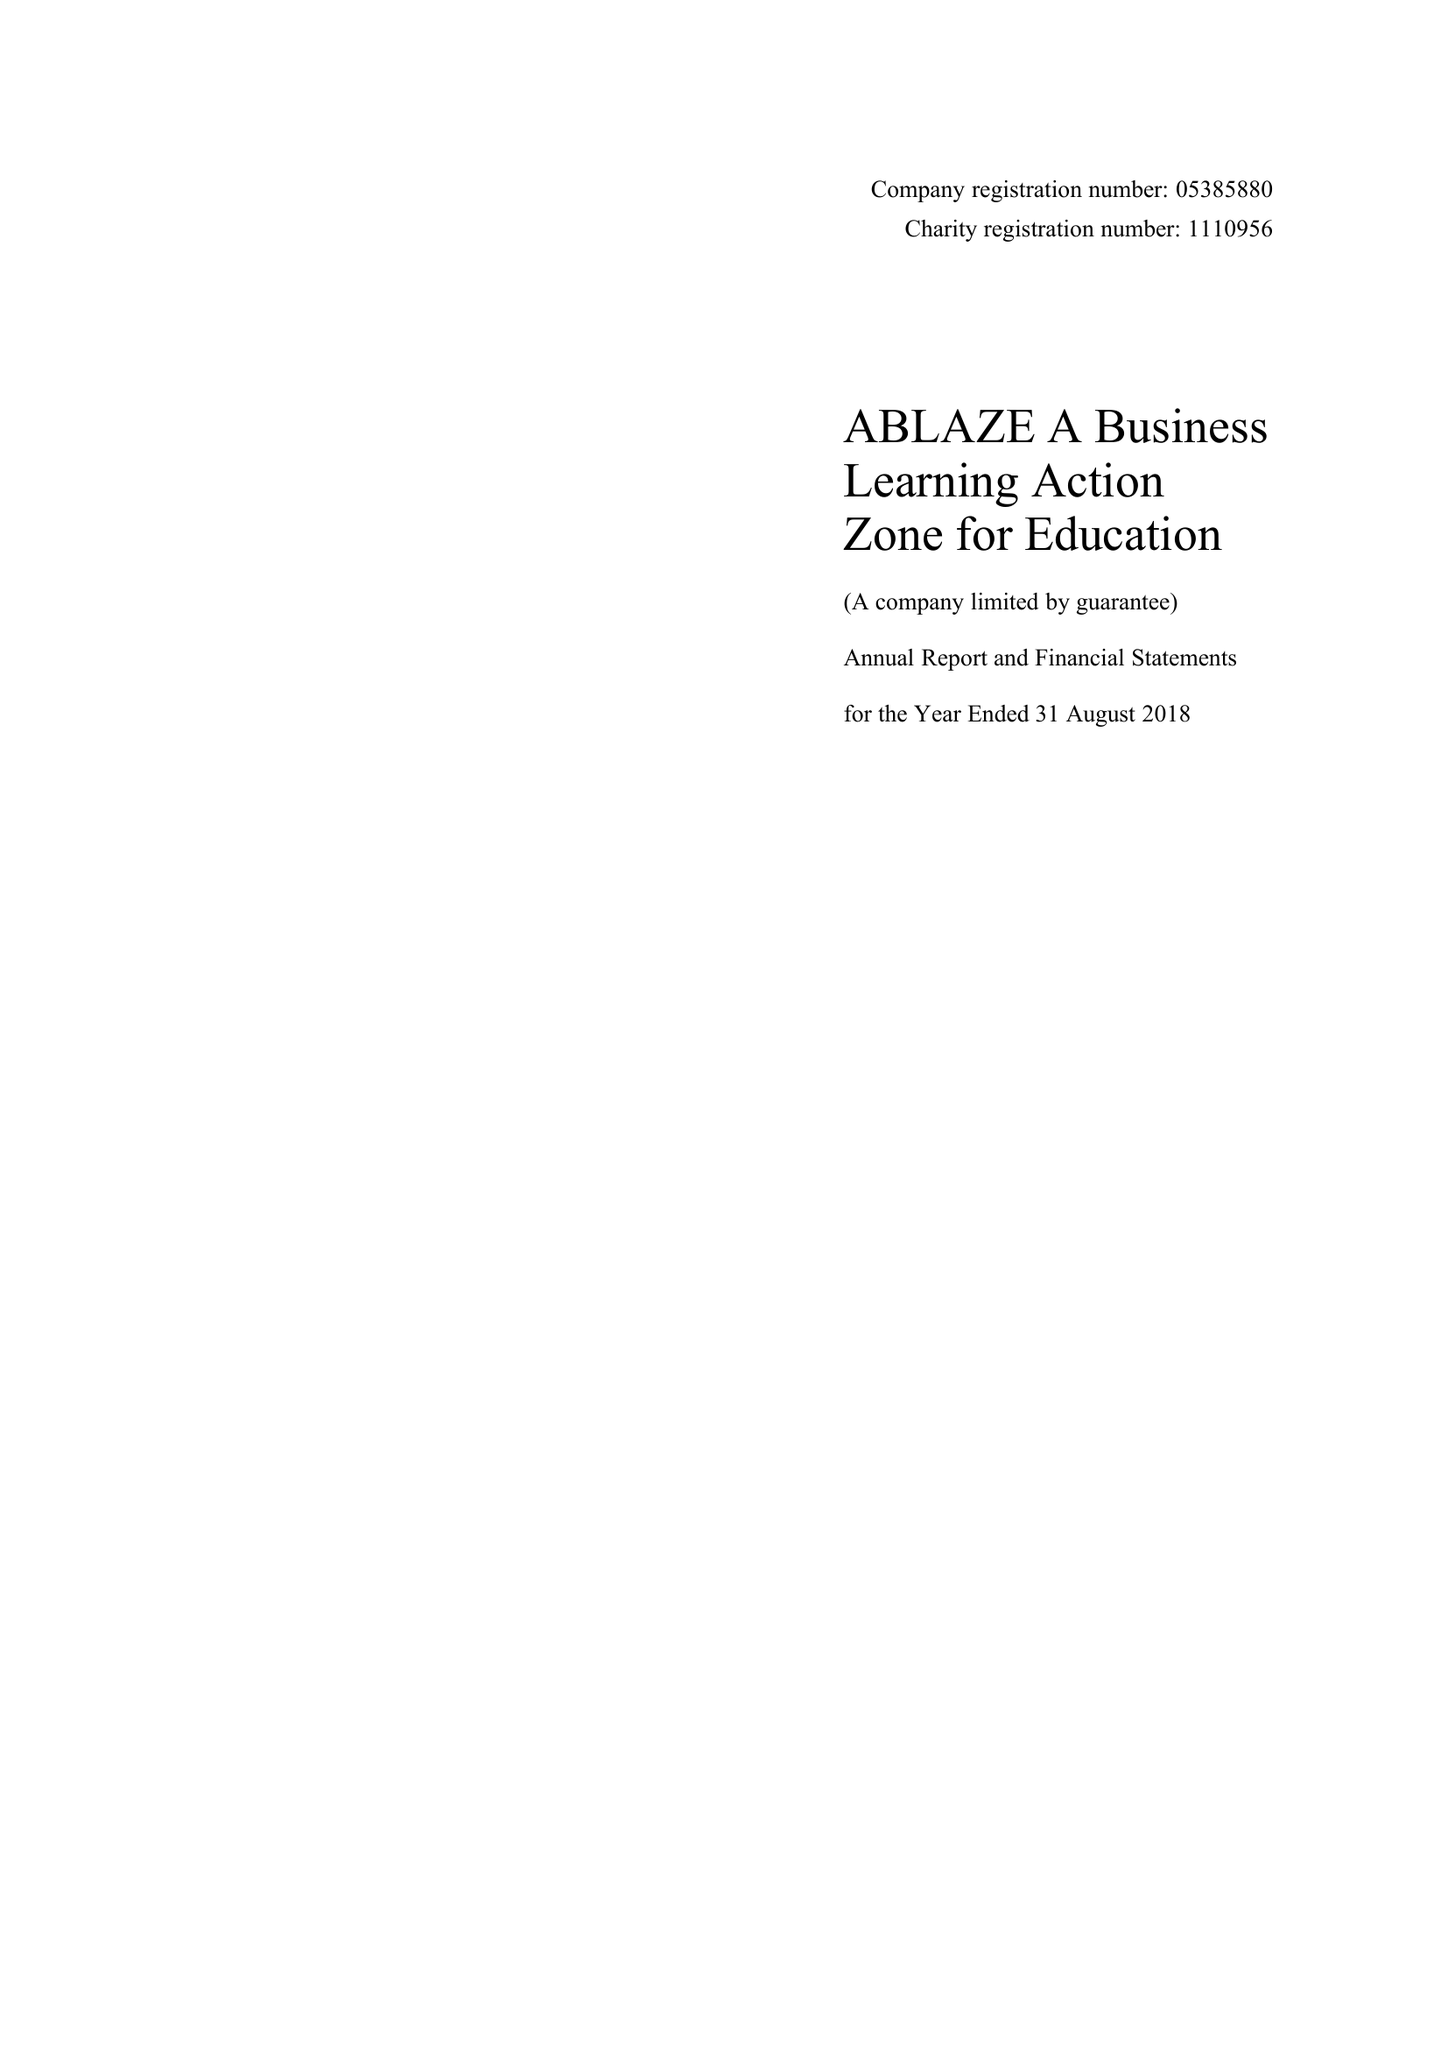What is the value for the charity_number?
Answer the question using a single word or phrase. 1110956 